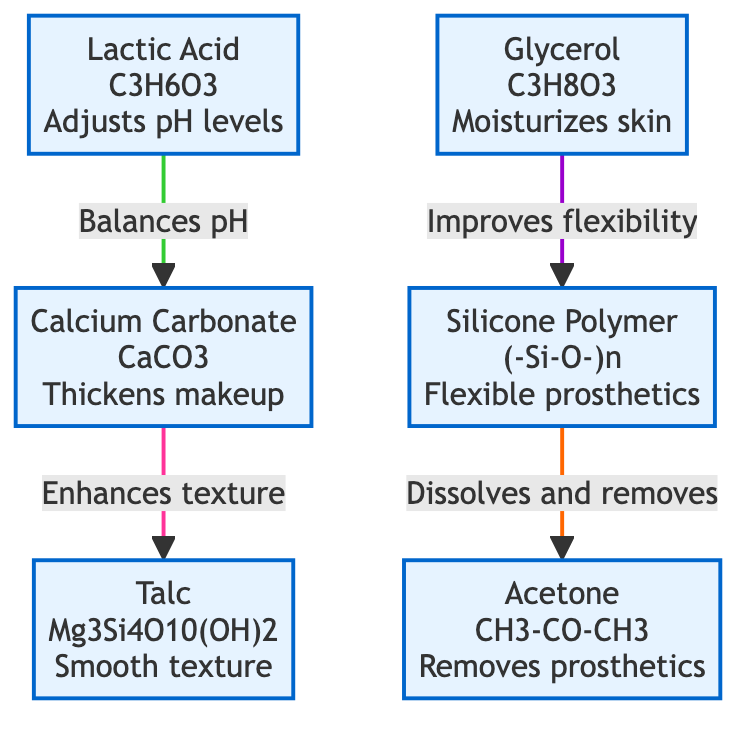What is the molecular structure of silicone polymer? The molecular structure of silicone polymer is represented as (-Si-O-)n, where "n" indicates the number of repeating units.
Answer: (-Si-O-)n How many total compounds are shown in the diagram? The diagram presents a total of six compounds, as indicated by the six nodes labeled with different chemical compounds.
Answer: 6 Which compound is used to remove prosthetics? Acetone is identified in the diagram with a note stating that it is used to remove prosthetics, indicating its function in this context.
Answer: Acetone What compound is used to thicken makeup? The diagram shows that calcium carbonate is responsible for thickening makeup, as it is specifically labeled for that purpose.
Answer: Calcium Carbonate Which two compounds contribute to texture improvement and flexibility, respectively? The diagram indicates that talc enhances texture while glycerol improves flexibility, connecting these compounds to their specific functions in the makeup application.
Answer: Talc and Glycerol What role does lactic acid play in the diagram? Lactic acid is indicated to adjust the pH levels, which is crucial for maintaining the skin’s health during makeup application.
Answer: Adjusts pH levels Which compound is linked to silicone polymer as improving its flexibility? Glycerol is specifically linked to silicone polymer in the diagram as enhancing its flexibility during the application on skin.
Answer: Glycerol What is the relationship between lactic acid and calcium carbonate? Lactic acid balances the pH levels of the makeup, which then allows calcium carbonate to thicken the makeup effectively. This indicates a functional interaction where the adjustment of pH is a prerequisite for the thickening process.
Answer: Balances pH What is the common function of the compounds that are connected to silicone polymer? The connected compounds like acetone and glycerol serve to either enhance or remove silicone polymer, indicating their relevance in the application and removal process of the makeup.
Answer: Flexible prosthetics 